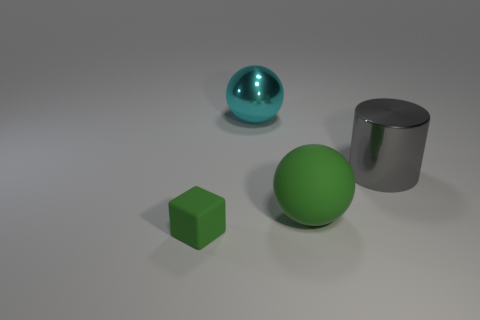Add 3 tiny rubber cylinders. How many objects exist? 7 Subtract all cylinders. How many objects are left? 3 Subtract 1 cyan spheres. How many objects are left? 3 Subtract all tiny green matte things. Subtract all gray blocks. How many objects are left? 3 Add 3 small objects. How many small objects are left? 4 Add 1 rubber objects. How many rubber objects exist? 3 